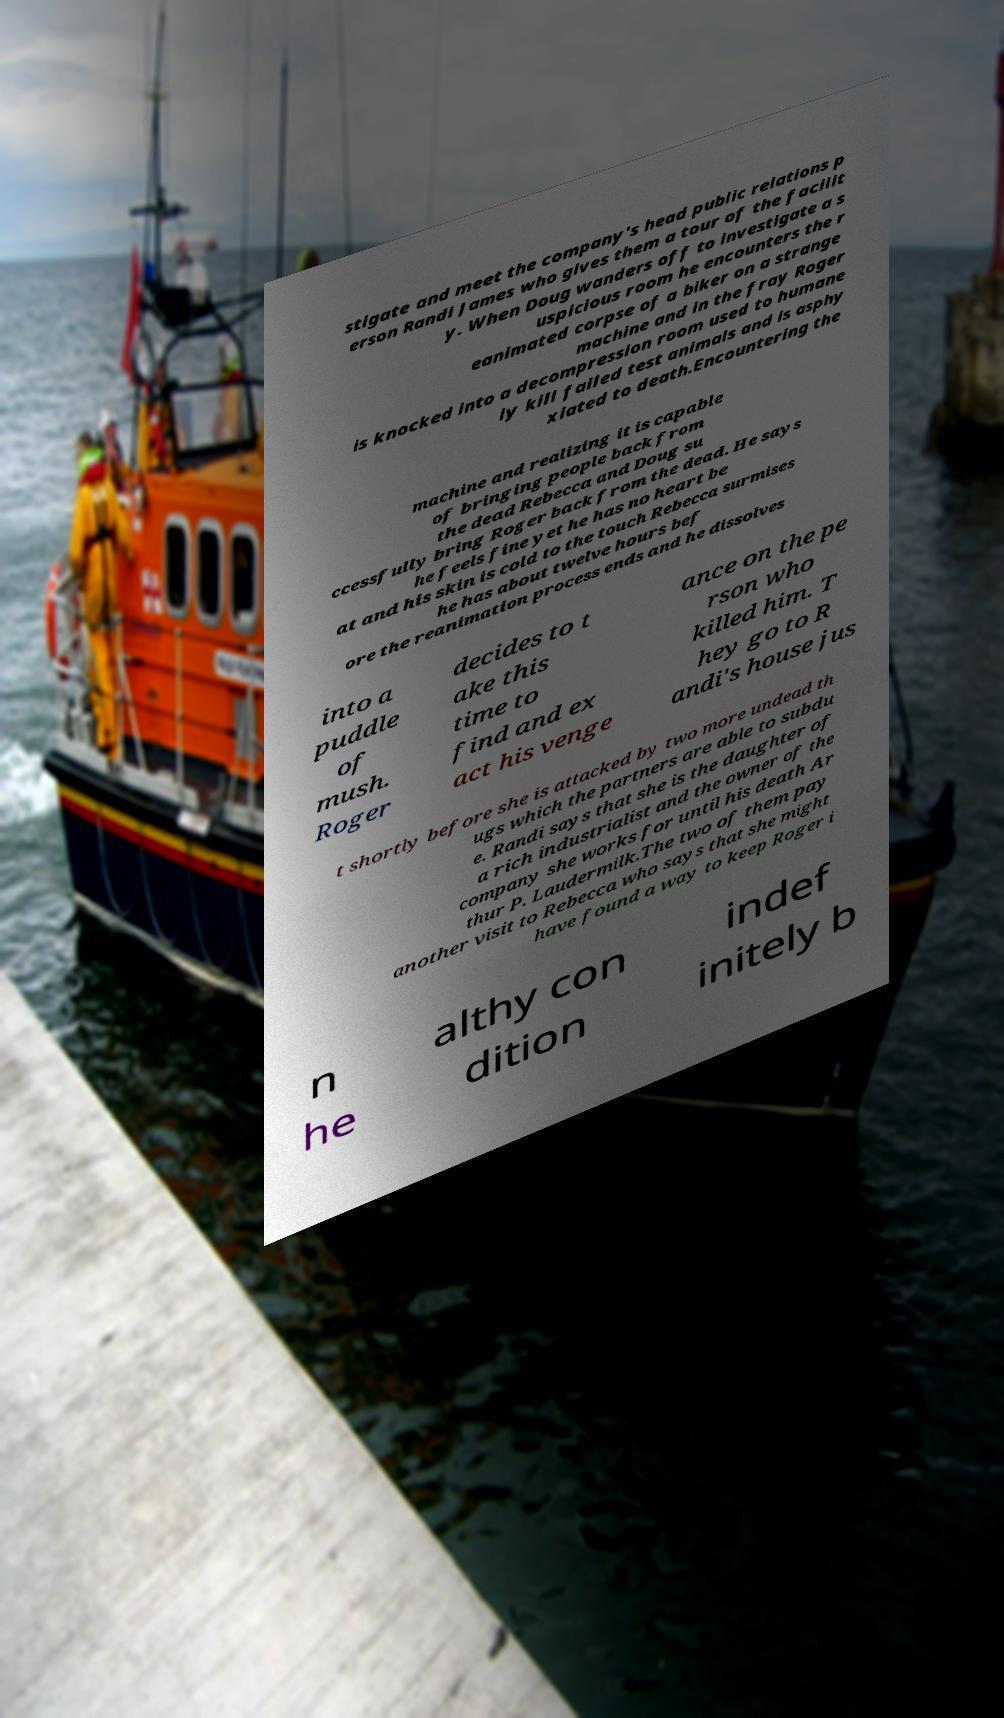Could you extract and type out the text from this image? stigate and meet the company's head public relations p erson Randi James who gives them a tour of the facilit y. When Doug wanders off to investigate a s uspicious room he encounters the r eanimated corpse of a biker on a strange machine and in the fray Roger is knocked into a decompression room used to humane ly kill failed test animals and is asphy xiated to death.Encountering the machine and realizing it is capable of bringing people back from the dead Rebecca and Doug su ccessfully bring Roger back from the dead. He says he feels fine yet he has no heart be at and his skin is cold to the touch Rebecca surmises he has about twelve hours bef ore the reanimation process ends and he dissolves into a puddle of mush. Roger decides to t ake this time to find and ex act his venge ance on the pe rson who killed him. T hey go to R andi's house jus t shortly before she is attacked by two more undead th ugs which the partners are able to subdu e. Randi says that she is the daughter of a rich industrialist and the owner of the company she works for until his death Ar thur P. Laudermilk.The two of them pay another visit to Rebecca who says that she might have found a way to keep Roger i n he althy con dition indef initely b 